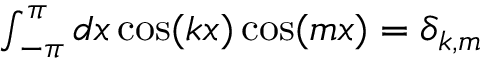Convert formula to latex. <formula><loc_0><loc_0><loc_500><loc_500>\begin{array} { r } { \int _ { - \pi } ^ { \pi } d x \cos ( k x ) \cos ( m x ) = \delta _ { k , m } } \end{array}</formula> 